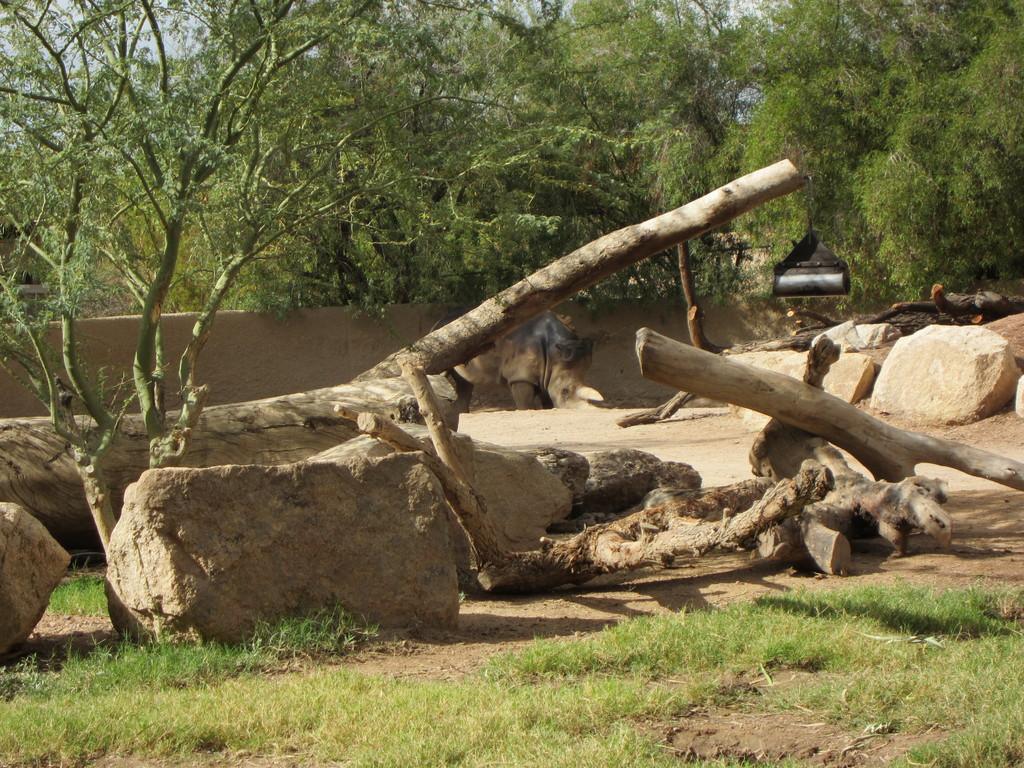Please provide a concise description of this image. This picture is clicked outside. In the foreground we can see the green grass. In the center we can see the wooden objects. In the background there is an animal like thing and we can see the trees and sky and some other objects. 